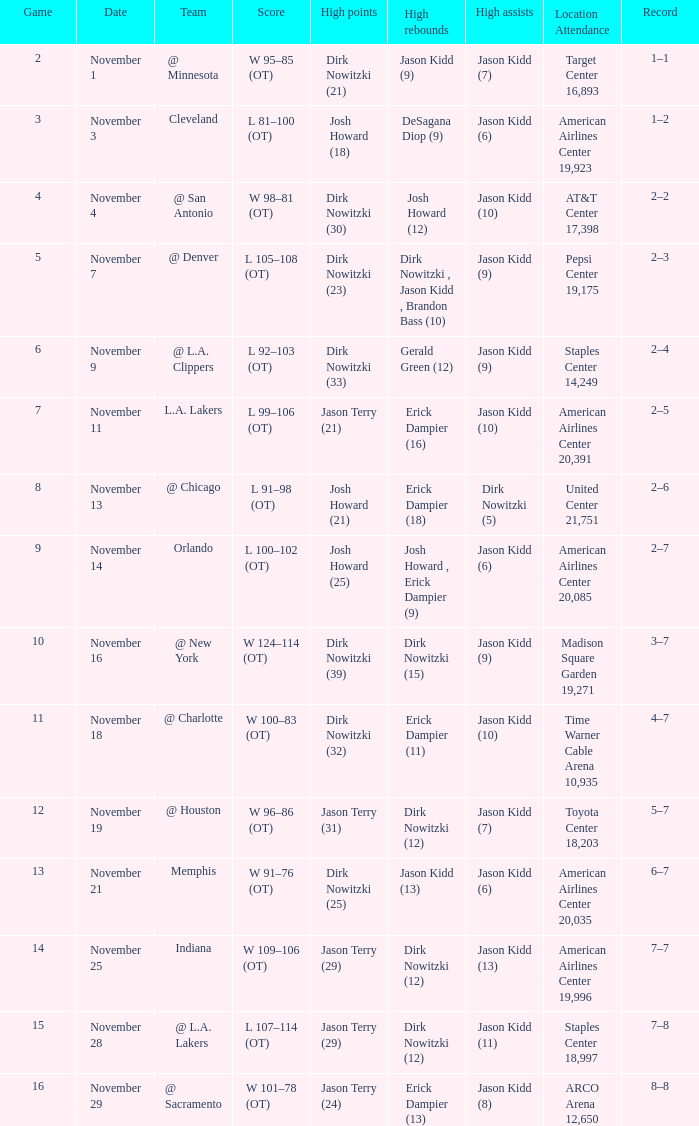On november 1, which game has the lowest score? 2.0. 